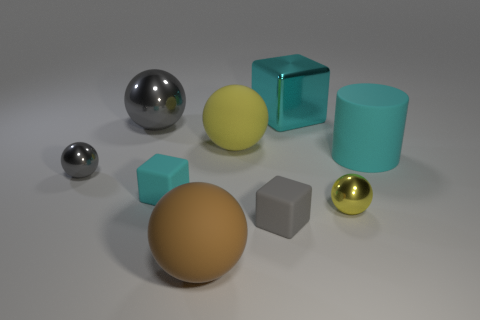Is there anything else that has the same shape as the large cyan matte thing?
Keep it short and to the point. No. There is a shiny object that is behind the big cylinder and left of the large brown sphere; how big is it?
Provide a short and direct response. Large. How many metallic things are small green balls or blocks?
Your answer should be compact. 1. Are there more gray metallic objects to the left of the big brown ball than tiny brown cubes?
Give a very brief answer. Yes. There is a ball that is to the right of the tiny gray rubber block; what is its material?
Provide a short and direct response. Metal. How many large yellow spheres have the same material as the tiny cyan thing?
Your answer should be compact. 1. What is the shape of the big rubber thing that is on the left side of the small gray matte object and behind the tiny gray rubber object?
Offer a very short reply. Sphere. How many things are balls behind the yellow matte thing or cubes that are to the left of the large cyan block?
Make the answer very short. 3. Is the number of cylinders on the left side of the big rubber cylinder the same as the number of tiny rubber things behind the small yellow ball?
Offer a very short reply. No. What shape is the tiny thing that is in front of the tiny metal ball that is to the right of the large brown ball?
Provide a succinct answer. Cube. 